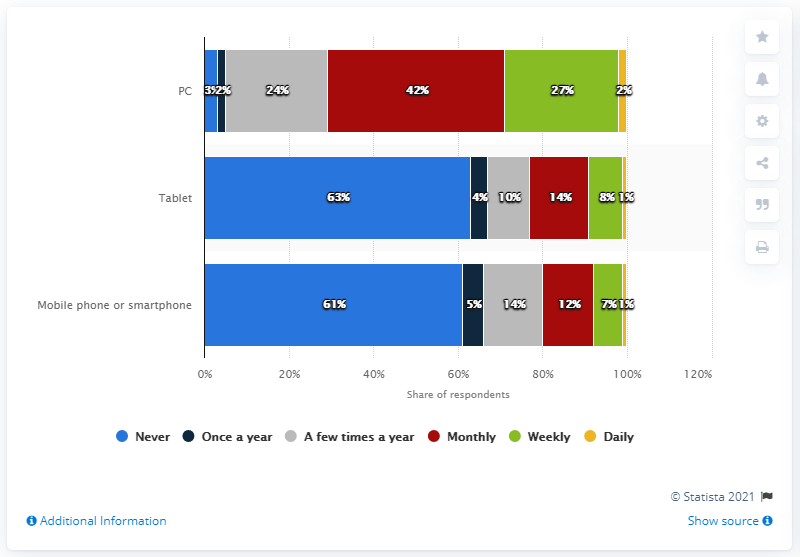Highlight a few significant elements in this photo. The sum of all the red bars in the chart is 68. The highest percentage value in the tablet category (blue bar) is 63%. 